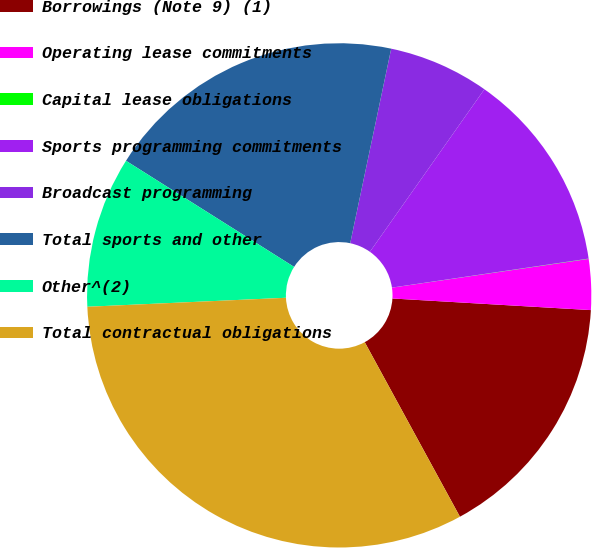<chart> <loc_0><loc_0><loc_500><loc_500><pie_chart><fcel>Borrowings (Note 9) (1)<fcel>Operating lease commitments<fcel>Capital lease obligations<fcel>Sports programming commitments<fcel>Broadcast programming<fcel>Total sports and other<fcel>Other^(2)<fcel>Total contractual obligations<nl><fcel>16.12%<fcel>3.24%<fcel>0.02%<fcel>12.9%<fcel>6.46%<fcel>19.34%<fcel>9.68%<fcel>32.22%<nl></chart> 